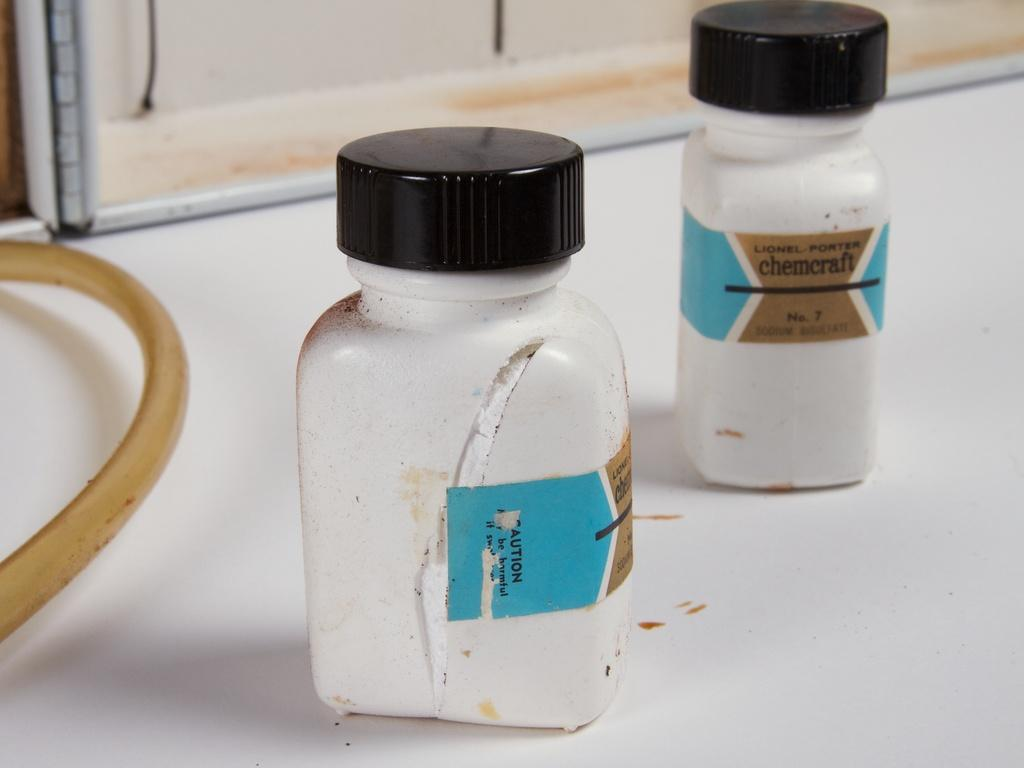Provide a one-sentence caption for the provided image. Two bottles of chemcraft powder are cut open on a white counter. 